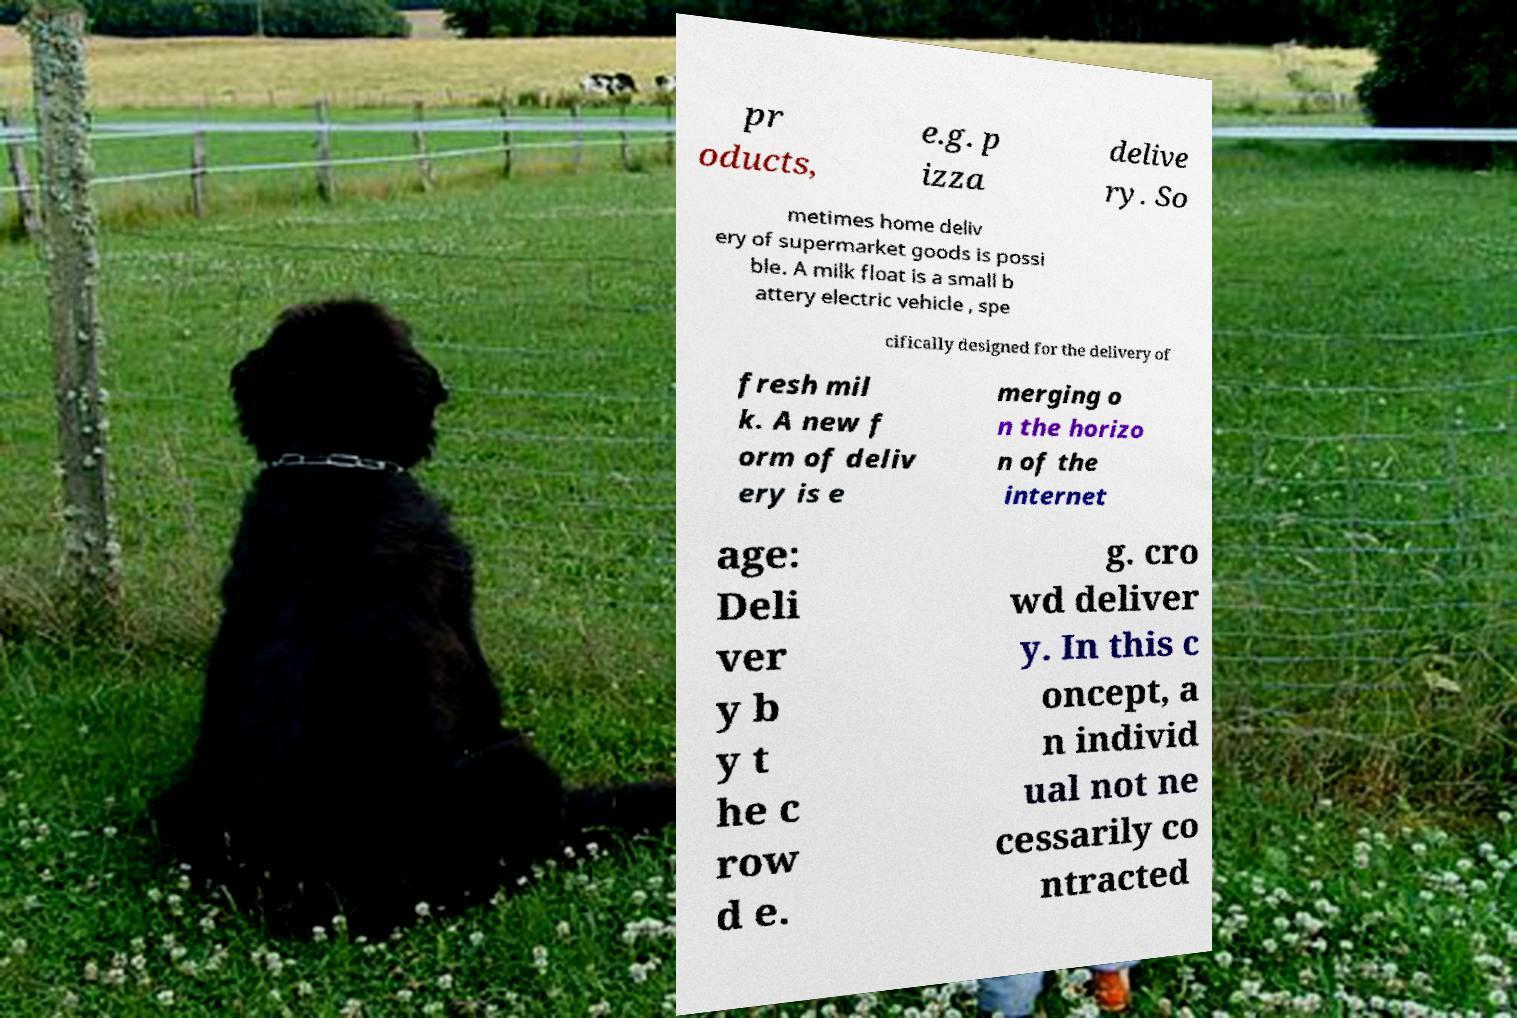I need the written content from this picture converted into text. Can you do that? pr oducts, e.g. p izza delive ry. So metimes home deliv ery of supermarket goods is possi ble. A milk float is a small b attery electric vehicle , spe cifically designed for the delivery of fresh mil k. A new f orm of deliv ery is e merging o n the horizo n of the internet age: Deli ver y b y t he c row d e. g. cro wd deliver y. In this c oncept, a n individ ual not ne cessarily co ntracted 